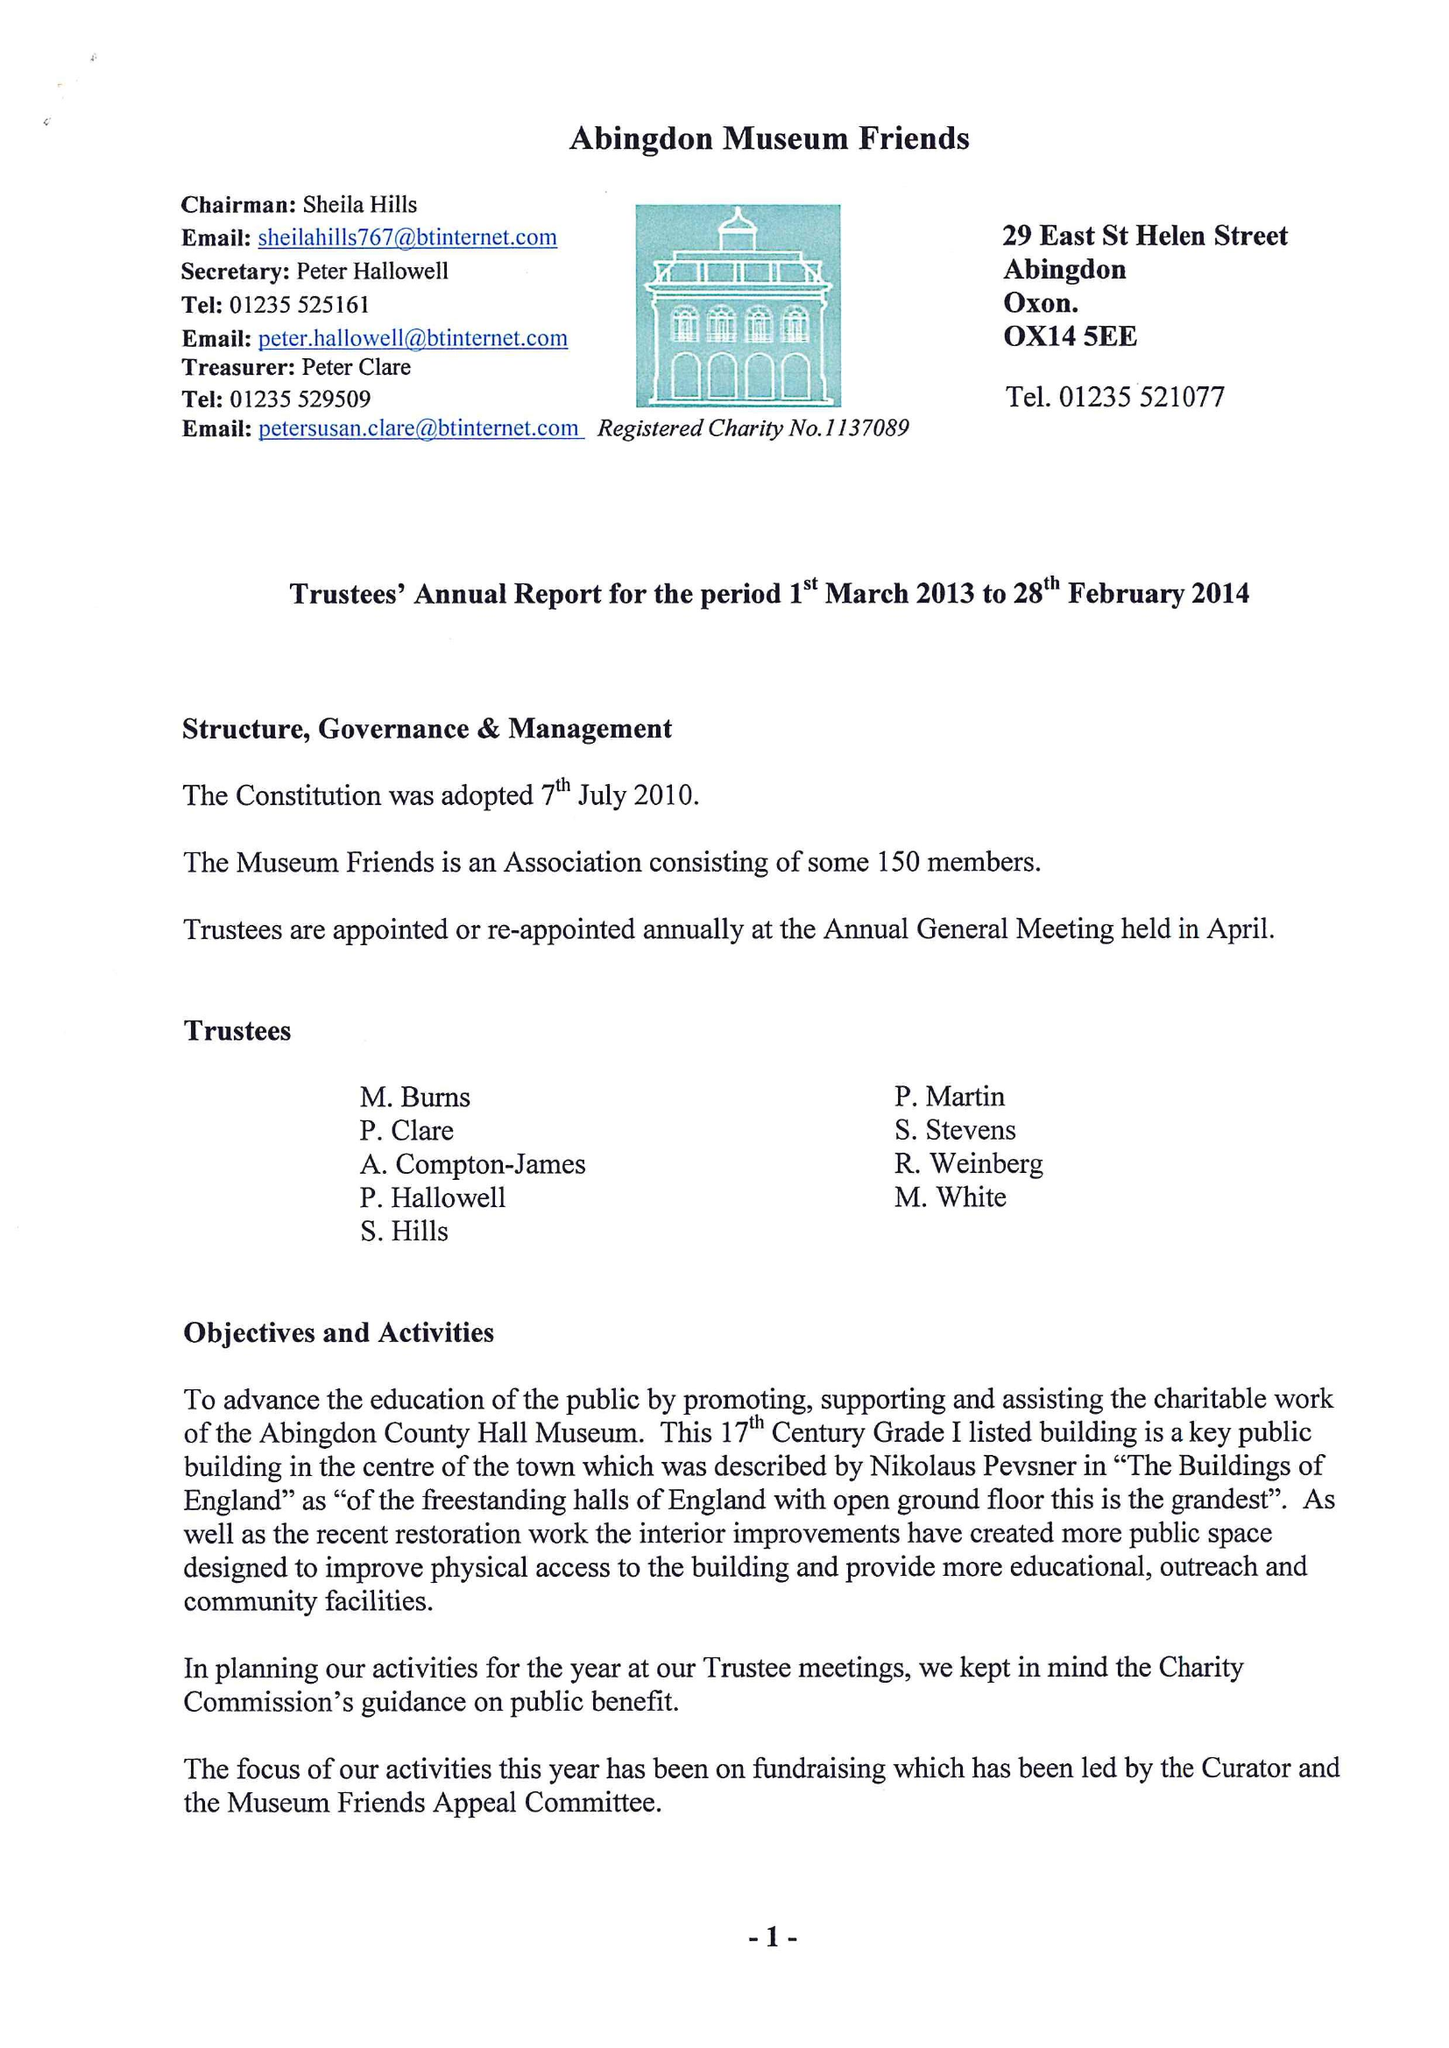What is the value for the address__postcode?
Answer the question using a single word or phrase. OX14 1JD 